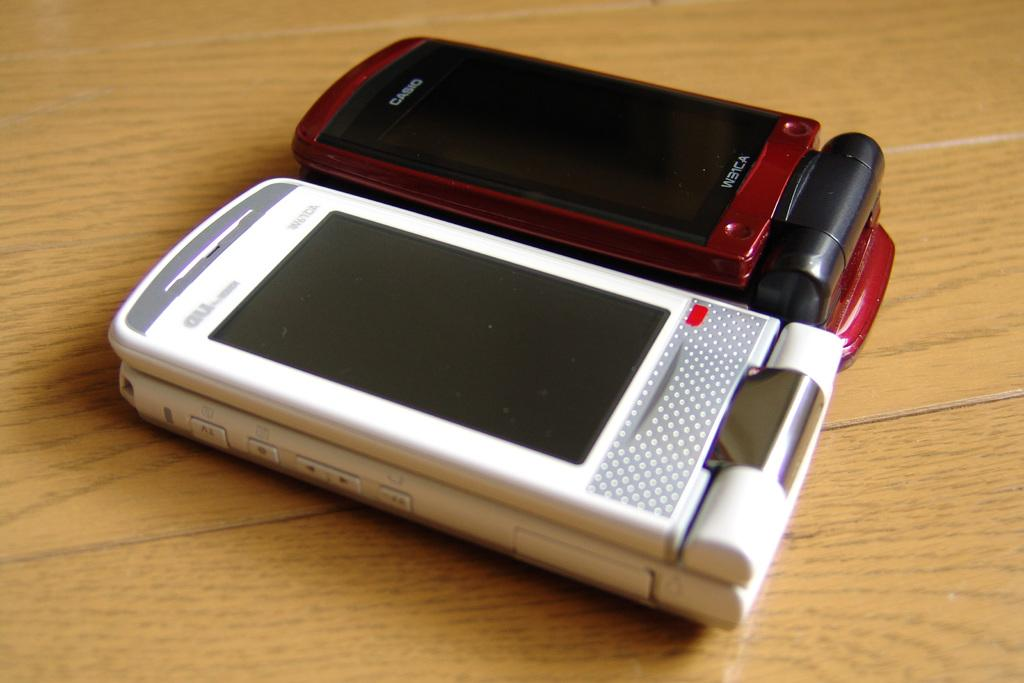Provide a one-sentence caption for the provided image. A maroon Casio flip phone next to another white flip phone on a table. 